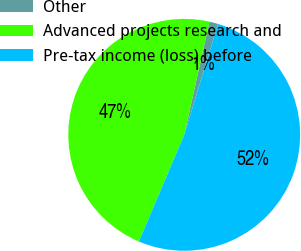Convert chart. <chart><loc_0><loc_0><loc_500><loc_500><pie_chart><fcel>Other<fcel>Advanced projects research and<fcel>Pre-tax income (loss) before<nl><fcel>1.21%<fcel>47.1%<fcel>51.69%<nl></chart> 